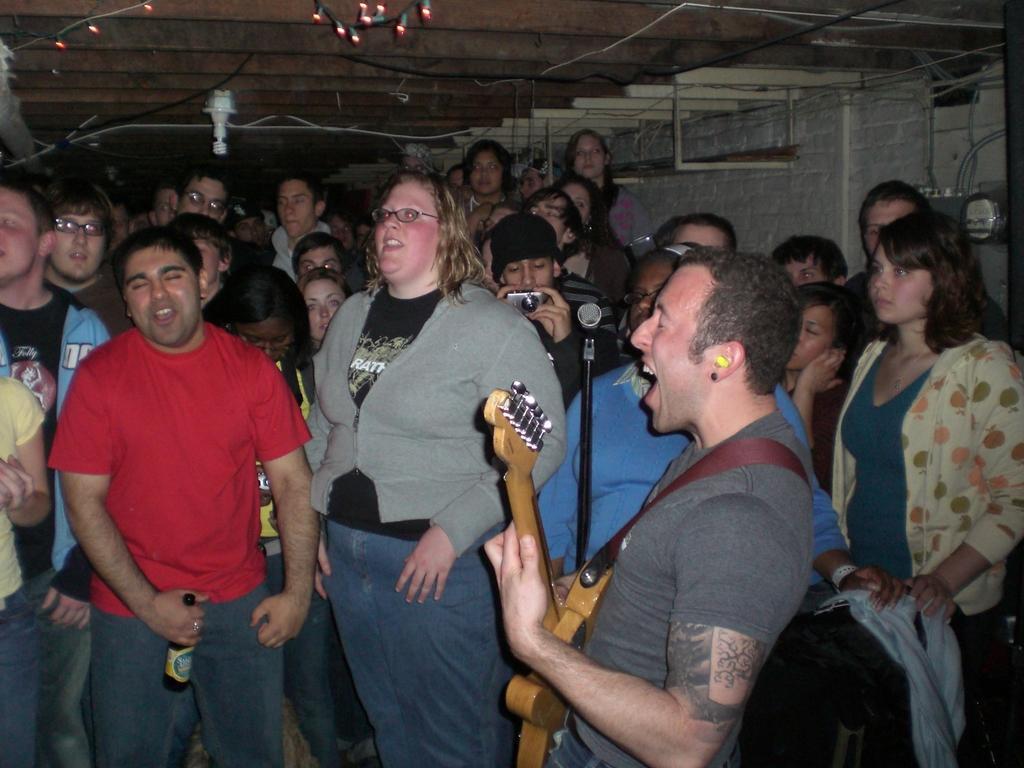Could you give a brief overview of what you see in this image? In the image there is a man using a guitar singing on mic and in front there are people looking at him and over the ceiling there are some lights. 